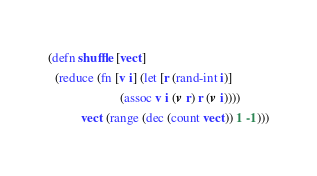Convert code to text. <code><loc_0><loc_0><loc_500><loc_500><_Clojure_>(defn shuffle [vect]
  (reduce (fn [v i] (let [r (rand-int i)]
                      (assoc v i (v r) r (v i))))
          vect (range (dec (count vect)) 1 -1)))
</code> 